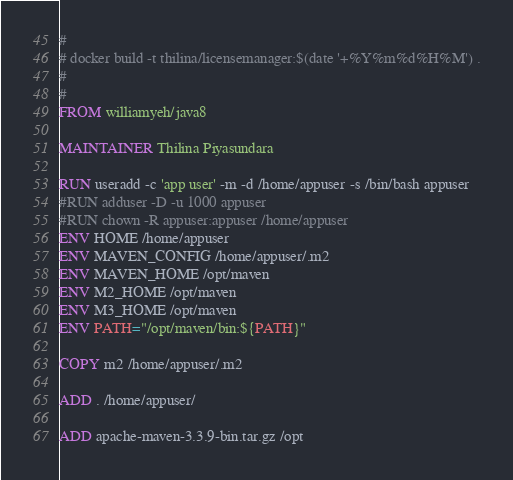<code> <loc_0><loc_0><loc_500><loc_500><_Dockerfile_>#
# docker build -t thilina/licensemanager:$(date '+%Y%m%d%H%M') .
#
#
FROM williamyeh/java8

MAINTAINER Thilina Piyasundara 

RUN useradd -c 'app user' -m -d /home/appuser -s /bin/bash appuser
#RUN adduser -D -u 1000 appuser
#RUN chown -R appuser:appuser /home/appuser
ENV HOME /home/appuser
ENV MAVEN_CONFIG /home/appuser/.m2 
ENV MAVEN_HOME /opt/maven
ENV M2_HOME /opt/maven
ENV M3_HOME /opt/maven
ENV PATH="/opt/maven/bin:${PATH}"

COPY m2 /home/appuser/.m2

ADD . /home/appuser/

ADD apache-maven-3.3.9-bin.tar.gz /opt</code> 